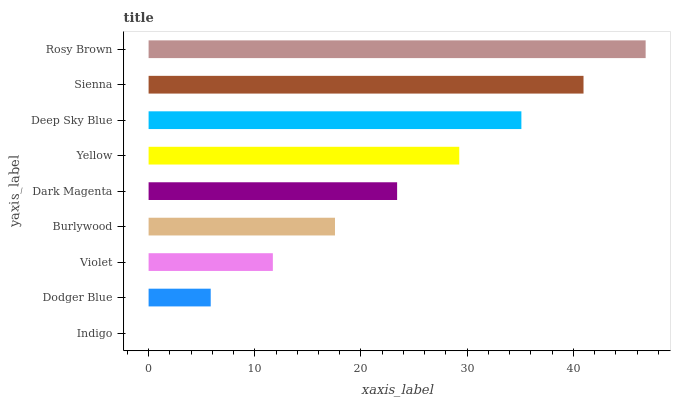Is Indigo the minimum?
Answer yes or no. Yes. Is Rosy Brown the maximum?
Answer yes or no. Yes. Is Dodger Blue the minimum?
Answer yes or no. No. Is Dodger Blue the maximum?
Answer yes or no. No. Is Dodger Blue greater than Indigo?
Answer yes or no. Yes. Is Indigo less than Dodger Blue?
Answer yes or no. Yes. Is Indigo greater than Dodger Blue?
Answer yes or no. No. Is Dodger Blue less than Indigo?
Answer yes or no. No. Is Dark Magenta the high median?
Answer yes or no. Yes. Is Dark Magenta the low median?
Answer yes or no. Yes. Is Burlywood the high median?
Answer yes or no. No. Is Deep Sky Blue the low median?
Answer yes or no. No. 